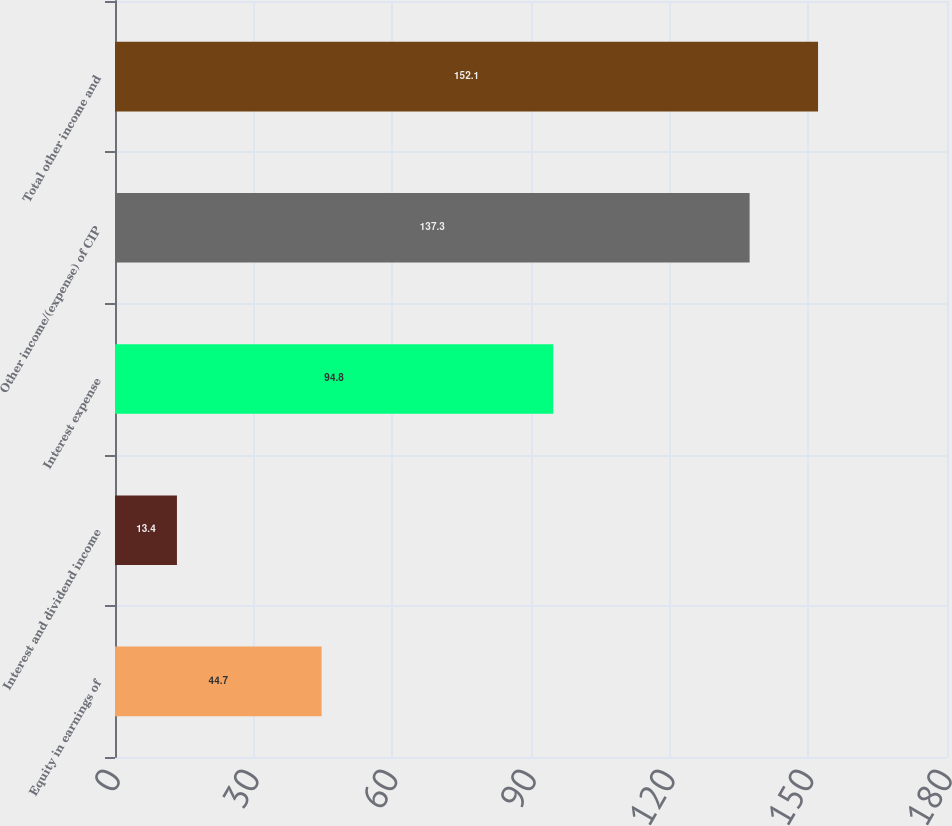Convert chart to OTSL. <chart><loc_0><loc_0><loc_500><loc_500><bar_chart><fcel>Equity in earnings of<fcel>Interest and dividend income<fcel>Interest expense<fcel>Other income/(expense) of CIP<fcel>Total other income and<nl><fcel>44.7<fcel>13.4<fcel>94.8<fcel>137.3<fcel>152.1<nl></chart> 